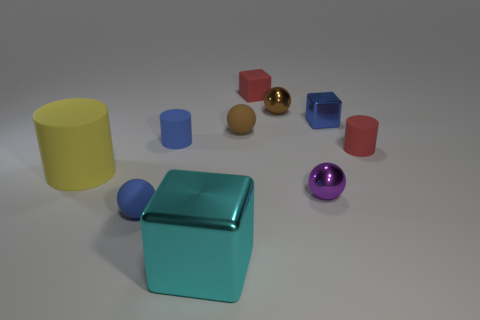What number of things are either tiny objects that are on the left side of the tiny purple metal ball or metallic objects right of the big block?
Your response must be concise. 7. What number of other objects are there of the same size as the blue cylinder?
Offer a terse response. 7. Is the color of the rubber sphere that is in front of the big cylinder the same as the large rubber cylinder?
Provide a short and direct response. No. There is a metallic thing that is behind the purple metallic ball and to the right of the brown metal sphere; what size is it?
Give a very brief answer. Small. How many large things are either purple things or red cylinders?
Give a very brief answer. 0. There is a red thing that is on the right side of the matte block; what is its shape?
Offer a very short reply. Cylinder. How many large gray metal spheres are there?
Your response must be concise. 0. Does the large cylinder have the same material as the tiny blue block?
Make the answer very short. No. Is the number of cyan objects that are in front of the brown rubber sphere greater than the number of gray cubes?
Offer a very short reply. Yes. What number of things are small brown shiny objects or tiny things on the right side of the matte block?
Offer a terse response. 4. 